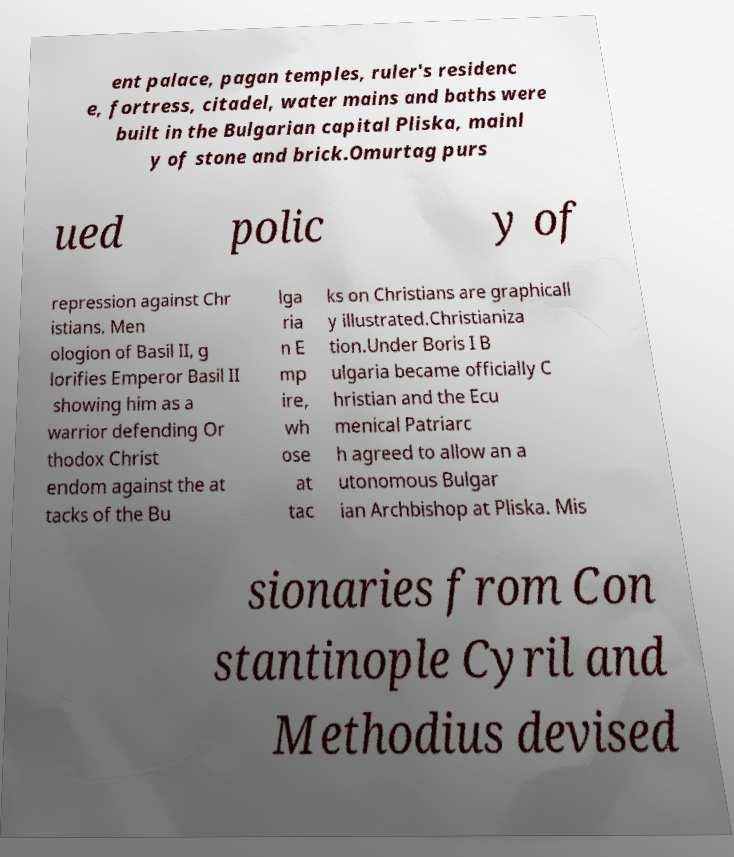Could you assist in decoding the text presented in this image and type it out clearly? ent palace, pagan temples, ruler's residenc e, fortress, citadel, water mains and baths were built in the Bulgarian capital Pliska, mainl y of stone and brick.Omurtag purs ued polic y of repression against Chr istians. Men ologion of Basil II, g lorifies Emperor Basil II showing him as a warrior defending Or thodox Christ endom against the at tacks of the Bu lga ria n E mp ire, wh ose at tac ks on Christians are graphicall y illustrated.Christianiza tion.Under Boris I B ulgaria became officially C hristian and the Ecu menical Patriarc h agreed to allow an a utonomous Bulgar ian Archbishop at Pliska. Mis sionaries from Con stantinople Cyril and Methodius devised 